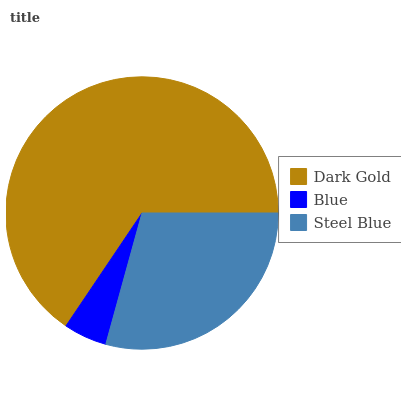Is Blue the minimum?
Answer yes or no. Yes. Is Dark Gold the maximum?
Answer yes or no. Yes. Is Steel Blue the minimum?
Answer yes or no. No. Is Steel Blue the maximum?
Answer yes or no. No. Is Steel Blue greater than Blue?
Answer yes or no. Yes. Is Blue less than Steel Blue?
Answer yes or no. Yes. Is Blue greater than Steel Blue?
Answer yes or no. No. Is Steel Blue less than Blue?
Answer yes or no. No. Is Steel Blue the high median?
Answer yes or no. Yes. Is Steel Blue the low median?
Answer yes or no. Yes. Is Dark Gold the high median?
Answer yes or no. No. Is Dark Gold the low median?
Answer yes or no. No. 